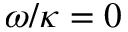<formula> <loc_0><loc_0><loc_500><loc_500>\omega / \kappa = 0</formula> 